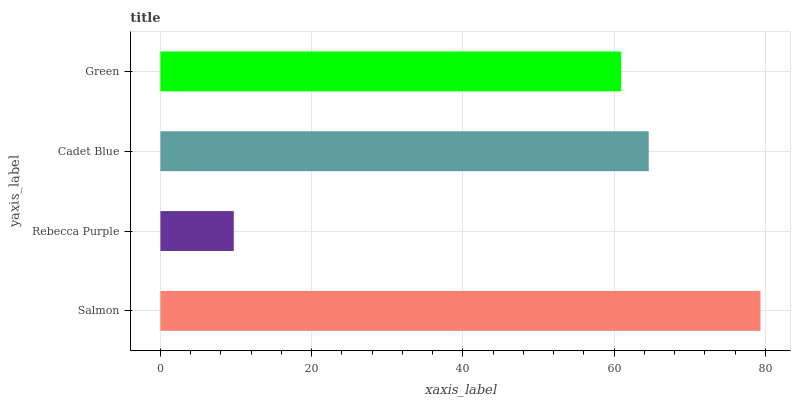Is Rebecca Purple the minimum?
Answer yes or no. Yes. Is Salmon the maximum?
Answer yes or no. Yes. Is Cadet Blue the minimum?
Answer yes or no. No. Is Cadet Blue the maximum?
Answer yes or no. No. Is Cadet Blue greater than Rebecca Purple?
Answer yes or no. Yes. Is Rebecca Purple less than Cadet Blue?
Answer yes or no. Yes. Is Rebecca Purple greater than Cadet Blue?
Answer yes or no. No. Is Cadet Blue less than Rebecca Purple?
Answer yes or no. No. Is Cadet Blue the high median?
Answer yes or no. Yes. Is Green the low median?
Answer yes or no. Yes. Is Rebecca Purple the high median?
Answer yes or no. No. Is Salmon the low median?
Answer yes or no. No. 